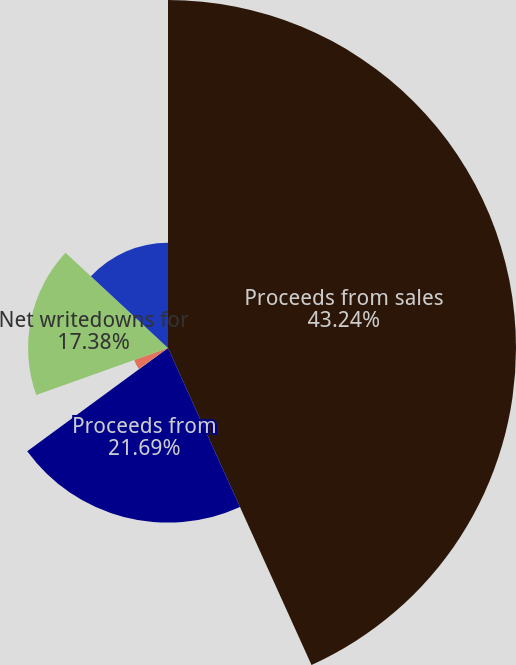Convert chart to OTSL. <chart><loc_0><loc_0><loc_500><loc_500><pie_chart><fcel>Proceeds from sales<fcel>Proceeds from<fcel>Gross investment gains from<fcel>Gross investment losses from<fcel>Net writedowns for<fcel>Writedowns for impairments on<nl><fcel>43.23%<fcel>21.69%<fcel>0.15%<fcel>4.46%<fcel>17.38%<fcel>13.08%<nl></chart> 